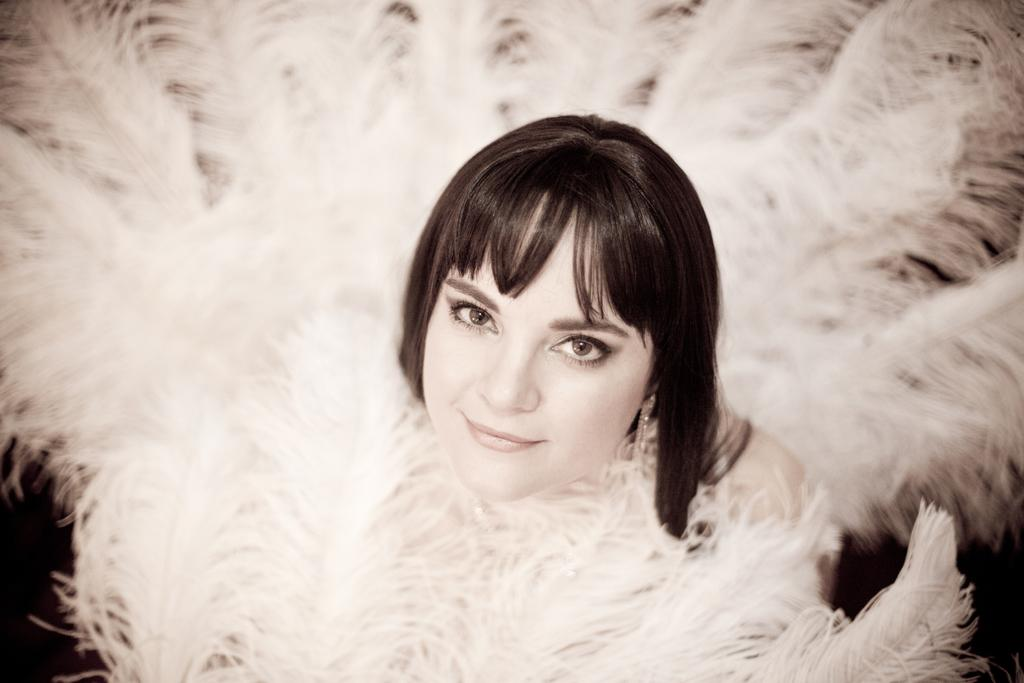Who is the main subject in the image? There is a lady in the center of the image. What is the lady doing in the image? The lady is smiling in the image. What is the lady wearing in the image? The lady is wearing a costume in the image. What emotion is the scarecrow displaying in the image? There is no scarecrow present in the image; it features a lady wearing a costume. How does the lady demonstrate her power in the image? The image does not depict the lady demonstrating any power; she is simply smiling. 